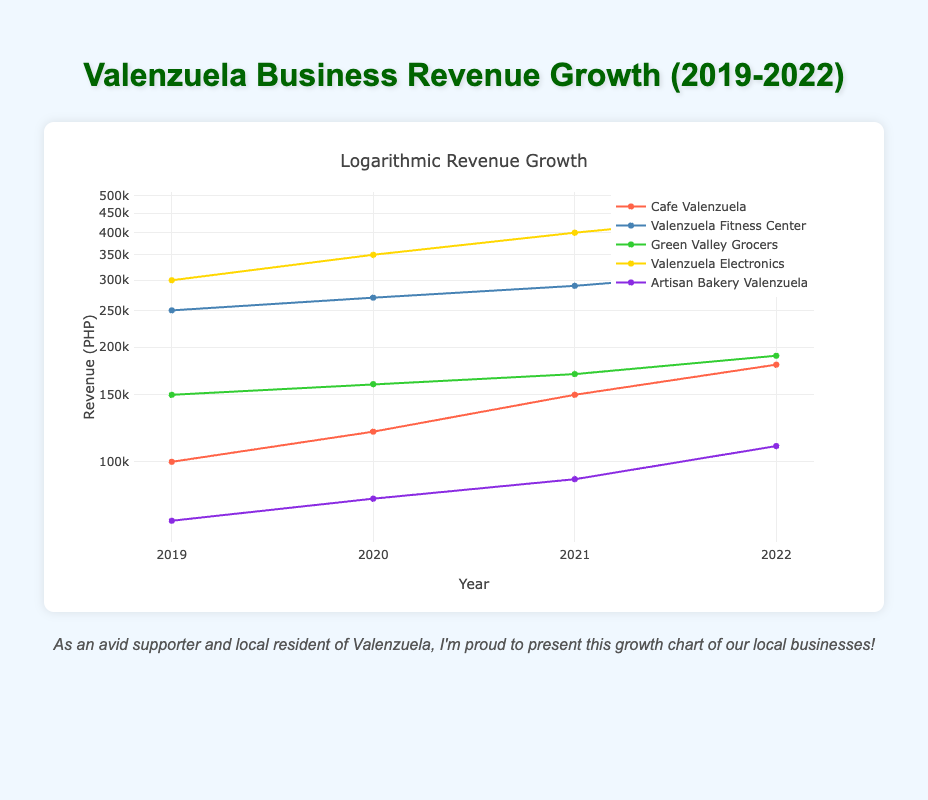What was the revenue of Cafe Valenzuela in 2021? According to the table, the revenue for Cafe Valenzuela in 2021 is listed as 150000 PHP. Thus, this value can be retrieved directly from the specified row for Cafe Valenzuela.
Answer: 150000 PHP Which business had the highest revenue in 2022? By comparing the revenue values across all businesses for the year 2022, Valenzuela Electronics has the highest revenue at 450000 PHP, while others have lower values in that year.
Answer: Valenzuela Electronics What is the total revenue growth of Valenzuela Fitness Center from 2019 to 2022? To find the total revenue growth for Valenzuela Fitness Center, we subtract the 2019 revenue from the 2022 revenue: 320000 - 250000 = 70000 PHP. This represents the overall growth in revenue over the four years.
Answer: 70000 PHP Did Green Valley Grocers have a consistent revenue increase every year from 2019 to 2022? Checking the values year by year, Green Valley Grocers shows revenue of 150000 in 2019, 160000 in 2020, 170000 in 2021, and 190000 in 2022. Since the values are increasing each year without any decreases, we can confirm that the growth was consistent.
Answer: Yes What was the average revenue for Artisan Bakery Valenzuela from 2019 to 2022? To find the average revenue, I will sum the revenues over the four years: 70000 + 80000 + 90000 + 110000 = 300000 PHP. Then, I divide by the number of years (4): 300000 / 4 = 75000 PHP. This gives us the average revenue for that business.
Answer: 75000 PHP Which year saw the highest revenue growth for Cafe Valenzuela? The revenue growth for Cafe Valenzuela can be calculated by finding the differences between each year's revenue: (120000 - 100000 = 20000), (150000 - 120000 = 30000), and (180000 - 150000 = 30000). The highest growth occurred between 2019 and 2020 at 20000 PHP, but then it changed with equal growth rates afterward, making this the peak year for growth.
Answer: 2020 What was the revenue difference between Valenzuela Electronics in 2019 and 2022? The revenue for Valenzuela Electronics in 2019 is 300000 PHP and in 2022 is 450000 PHP. To find the difference: 450000 - 300000 = 150000 PHP, indicating how much the revenue has increased over those years.
Answer: 150000 PHP Was the revenue of Artisan Bakery Valenzuela over 100000 PHP in 2022? Looking at the revenue for Artisan Bakery Valenzuela in 2022, it is recorded as 110000 PHP, which is indeed over 100000 PHP. Thus, the statement is accurate according to the provided data.
Answer: Yes What percentage increase in revenue did Green Valley Grocers see from 2019 to 2022? To calculate the percentage increase, first find the growth: 190000 - 150000 = 40000 PHP. Then use the formula for percentage increase: (40000 / 150000) * 100 = 26.67%. This indicates how revenue increased relative to the original 2019 figure.
Answer: 26.67% What was the lowest revenue recorded across all businesses in 2019? Reviewing each business's revenue from the year 2019, Cafe Valenzuela had the lowest revenue at 100000 PHP when compared to all other listed businesses. This confirms the ranking for that particular year.
Answer: 100000 PHP 